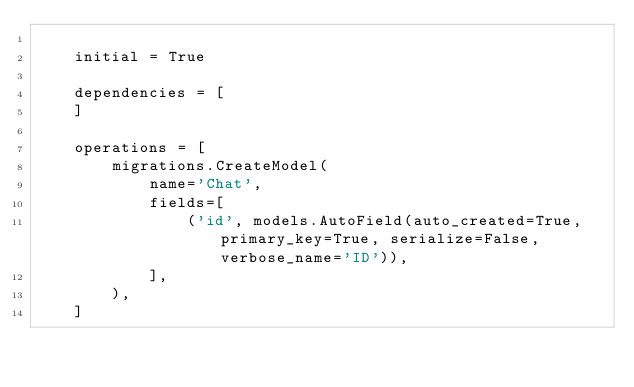Convert code to text. <code><loc_0><loc_0><loc_500><loc_500><_Python_>
    initial = True

    dependencies = [
    ]

    operations = [
        migrations.CreateModel(
            name='Chat',
            fields=[
                ('id', models.AutoField(auto_created=True, primary_key=True, serialize=False, verbose_name='ID')),
            ],
        ),
    ]
</code> 